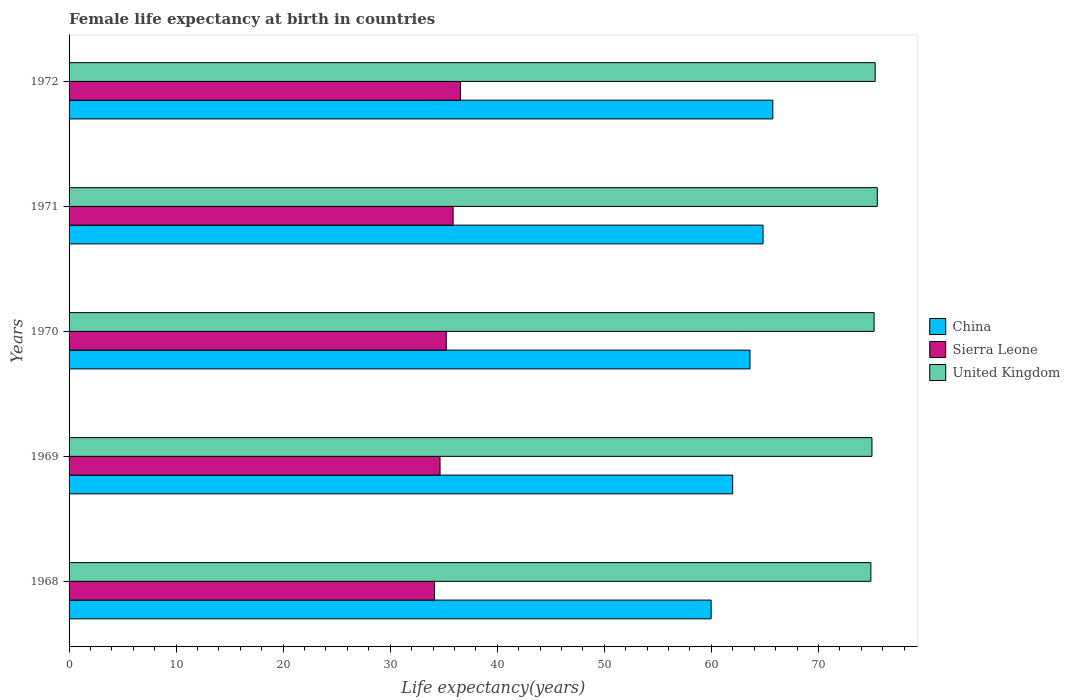Are the number of bars on each tick of the Y-axis equal?
Offer a terse response. Yes. How many bars are there on the 3rd tick from the top?
Your response must be concise. 3. What is the label of the 5th group of bars from the top?
Offer a terse response. 1968. What is the female life expectancy at birth in United Kingdom in 1968?
Make the answer very short. 74.9. Across all years, what is the maximum female life expectancy at birth in Sierra Leone?
Provide a short and direct response. 36.56. Across all years, what is the minimum female life expectancy at birth in China?
Ensure brevity in your answer.  59.98. In which year was the female life expectancy at birth in Sierra Leone minimum?
Your answer should be compact. 1968. What is the total female life expectancy at birth in Sierra Leone in the graph?
Provide a succinct answer. 176.46. What is the difference between the female life expectancy at birth in Sierra Leone in 1970 and that in 1972?
Give a very brief answer. -1.32. What is the difference between the female life expectancy at birth in Sierra Leone in 1970 and the female life expectancy at birth in China in 1968?
Ensure brevity in your answer.  -24.74. What is the average female life expectancy at birth in United Kingdom per year?
Offer a very short reply. 75.18. In the year 1968, what is the difference between the female life expectancy at birth in Sierra Leone and female life expectancy at birth in United Kingdom?
Your answer should be compact. -40.76. In how many years, is the female life expectancy at birth in United Kingdom greater than 30 years?
Your answer should be compact. 5. What is the ratio of the female life expectancy at birth in China in 1969 to that in 1972?
Keep it short and to the point. 0.94. Is the difference between the female life expectancy at birth in Sierra Leone in 1969 and 1972 greater than the difference between the female life expectancy at birth in United Kingdom in 1969 and 1972?
Make the answer very short. No. What is the difference between the highest and the second highest female life expectancy at birth in United Kingdom?
Keep it short and to the point. 0.2. What is the difference between the highest and the lowest female life expectancy at birth in United Kingdom?
Make the answer very short. 0.6. In how many years, is the female life expectancy at birth in United Kingdom greater than the average female life expectancy at birth in United Kingdom taken over all years?
Keep it short and to the point. 3. Is the sum of the female life expectancy at birth in China in 1970 and 1971 greater than the maximum female life expectancy at birth in United Kingdom across all years?
Provide a short and direct response. Yes. What does the 2nd bar from the top in 1971 represents?
Make the answer very short. Sierra Leone. What does the 2nd bar from the bottom in 1970 represents?
Make the answer very short. Sierra Leone. Is it the case that in every year, the sum of the female life expectancy at birth in Sierra Leone and female life expectancy at birth in China is greater than the female life expectancy at birth in United Kingdom?
Offer a very short reply. Yes. How many bars are there?
Provide a short and direct response. 15. Are the values on the major ticks of X-axis written in scientific E-notation?
Provide a succinct answer. No. Does the graph contain any zero values?
Your answer should be very brief. No. Does the graph contain grids?
Your answer should be compact. No. Where does the legend appear in the graph?
Offer a very short reply. Center right. How many legend labels are there?
Give a very brief answer. 3. What is the title of the graph?
Your response must be concise. Female life expectancy at birth in countries. Does "Jordan" appear as one of the legend labels in the graph?
Ensure brevity in your answer.  No. What is the label or title of the X-axis?
Make the answer very short. Life expectancy(years). What is the Life expectancy(years) in China in 1968?
Ensure brevity in your answer.  59.98. What is the Life expectancy(years) in Sierra Leone in 1968?
Ensure brevity in your answer.  34.14. What is the Life expectancy(years) of United Kingdom in 1968?
Ensure brevity in your answer.  74.9. What is the Life expectancy(years) of China in 1969?
Your answer should be very brief. 61.99. What is the Life expectancy(years) in Sierra Leone in 1969?
Ensure brevity in your answer.  34.66. What is the Life expectancy(years) in United Kingdom in 1969?
Your response must be concise. 75. What is the Life expectancy(years) in China in 1970?
Give a very brief answer. 63.61. What is the Life expectancy(years) of Sierra Leone in 1970?
Make the answer very short. 35.23. What is the Life expectancy(years) of United Kingdom in 1970?
Provide a succinct answer. 75.2. What is the Life expectancy(years) in China in 1971?
Your answer should be compact. 64.83. What is the Life expectancy(years) in Sierra Leone in 1971?
Make the answer very short. 35.88. What is the Life expectancy(years) in United Kingdom in 1971?
Your response must be concise. 75.5. What is the Life expectancy(years) in China in 1972?
Provide a succinct answer. 65.74. What is the Life expectancy(years) in Sierra Leone in 1972?
Make the answer very short. 36.56. What is the Life expectancy(years) in United Kingdom in 1972?
Keep it short and to the point. 75.3. Across all years, what is the maximum Life expectancy(years) in China?
Offer a very short reply. 65.74. Across all years, what is the maximum Life expectancy(years) in Sierra Leone?
Make the answer very short. 36.56. Across all years, what is the maximum Life expectancy(years) in United Kingdom?
Offer a terse response. 75.5. Across all years, what is the minimum Life expectancy(years) of China?
Offer a very short reply. 59.98. Across all years, what is the minimum Life expectancy(years) of Sierra Leone?
Ensure brevity in your answer.  34.14. Across all years, what is the minimum Life expectancy(years) in United Kingdom?
Your response must be concise. 74.9. What is the total Life expectancy(years) in China in the graph?
Give a very brief answer. 316.15. What is the total Life expectancy(years) of Sierra Leone in the graph?
Offer a terse response. 176.46. What is the total Life expectancy(years) of United Kingdom in the graph?
Offer a terse response. 375.9. What is the difference between the Life expectancy(years) of China in 1968 and that in 1969?
Your answer should be compact. -2.01. What is the difference between the Life expectancy(years) of Sierra Leone in 1968 and that in 1969?
Your answer should be compact. -0.52. What is the difference between the Life expectancy(years) of China in 1968 and that in 1970?
Your answer should be compact. -3.63. What is the difference between the Life expectancy(years) of Sierra Leone in 1968 and that in 1970?
Offer a very short reply. -1.1. What is the difference between the Life expectancy(years) in United Kingdom in 1968 and that in 1970?
Ensure brevity in your answer.  -0.3. What is the difference between the Life expectancy(years) of China in 1968 and that in 1971?
Make the answer very short. -4.85. What is the difference between the Life expectancy(years) in Sierra Leone in 1968 and that in 1971?
Provide a succinct answer. -1.74. What is the difference between the Life expectancy(years) of China in 1968 and that in 1972?
Your answer should be very brief. -5.76. What is the difference between the Life expectancy(years) of Sierra Leone in 1968 and that in 1972?
Provide a succinct answer. -2.42. What is the difference between the Life expectancy(years) in China in 1969 and that in 1970?
Give a very brief answer. -1.62. What is the difference between the Life expectancy(years) of Sierra Leone in 1969 and that in 1970?
Keep it short and to the point. -0.58. What is the difference between the Life expectancy(years) in United Kingdom in 1969 and that in 1970?
Offer a very short reply. -0.2. What is the difference between the Life expectancy(years) in China in 1969 and that in 1971?
Your answer should be compact. -2.84. What is the difference between the Life expectancy(years) of Sierra Leone in 1969 and that in 1971?
Offer a very short reply. -1.22. What is the difference between the Life expectancy(years) of China in 1969 and that in 1972?
Offer a very short reply. -3.75. What is the difference between the Life expectancy(years) of Sierra Leone in 1969 and that in 1972?
Ensure brevity in your answer.  -1.9. What is the difference between the Life expectancy(years) in United Kingdom in 1969 and that in 1972?
Provide a succinct answer. -0.3. What is the difference between the Life expectancy(years) of China in 1970 and that in 1971?
Offer a very short reply. -1.22. What is the difference between the Life expectancy(years) of Sierra Leone in 1970 and that in 1971?
Give a very brief answer. -0.64. What is the difference between the Life expectancy(years) of China in 1970 and that in 1972?
Make the answer very short. -2.13. What is the difference between the Life expectancy(years) in Sierra Leone in 1970 and that in 1972?
Your answer should be compact. -1.32. What is the difference between the Life expectancy(years) in China in 1971 and that in 1972?
Keep it short and to the point. -0.91. What is the difference between the Life expectancy(years) of Sierra Leone in 1971 and that in 1972?
Your answer should be compact. -0.68. What is the difference between the Life expectancy(years) of United Kingdom in 1971 and that in 1972?
Your response must be concise. 0.2. What is the difference between the Life expectancy(years) in China in 1968 and the Life expectancy(years) in Sierra Leone in 1969?
Provide a short and direct response. 25.32. What is the difference between the Life expectancy(years) of China in 1968 and the Life expectancy(years) of United Kingdom in 1969?
Provide a succinct answer. -15.02. What is the difference between the Life expectancy(years) in Sierra Leone in 1968 and the Life expectancy(years) in United Kingdom in 1969?
Provide a succinct answer. -40.86. What is the difference between the Life expectancy(years) of China in 1968 and the Life expectancy(years) of Sierra Leone in 1970?
Your response must be concise. 24.74. What is the difference between the Life expectancy(years) in China in 1968 and the Life expectancy(years) in United Kingdom in 1970?
Your response must be concise. -15.22. What is the difference between the Life expectancy(years) of Sierra Leone in 1968 and the Life expectancy(years) of United Kingdom in 1970?
Your response must be concise. -41.06. What is the difference between the Life expectancy(years) in China in 1968 and the Life expectancy(years) in Sierra Leone in 1971?
Make the answer very short. 24.1. What is the difference between the Life expectancy(years) of China in 1968 and the Life expectancy(years) of United Kingdom in 1971?
Provide a short and direct response. -15.52. What is the difference between the Life expectancy(years) of Sierra Leone in 1968 and the Life expectancy(years) of United Kingdom in 1971?
Keep it short and to the point. -41.36. What is the difference between the Life expectancy(years) of China in 1968 and the Life expectancy(years) of Sierra Leone in 1972?
Ensure brevity in your answer.  23.42. What is the difference between the Life expectancy(years) in China in 1968 and the Life expectancy(years) in United Kingdom in 1972?
Make the answer very short. -15.32. What is the difference between the Life expectancy(years) of Sierra Leone in 1968 and the Life expectancy(years) of United Kingdom in 1972?
Provide a short and direct response. -41.16. What is the difference between the Life expectancy(years) of China in 1969 and the Life expectancy(years) of Sierra Leone in 1970?
Ensure brevity in your answer.  26.75. What is the difference between the Life expectancy(years) of China in 1969 and the Life expectancy(years) of United Kingdom in 1970?
Offer a very short reply. -13.21. What is the difference between the Life expectancy(years) in Sierra Leone in 1969 and the Life expectancy(years) in United Kingdom in 1970?
Offer a very short reply. -40.55. What is the difference between the Life expectancy(years) of China in 1969 and the Life expectancy(years) of Sierra Leone in 1971?
Offer a terse response. 26.11. What is the difference between the Life expectancy(years) in China in 1969 and the Life expectancy(years) in United Kingdom in 1971?
Make the answer very short. -13.51. What is the difference between the Life expectancy(years) of Sierra Leone in 1969 and the Life expectancy(years) of United Kingdom in 1971?
Your answer should be compact. -40.84. What is the difference between the Life expectancy(years) in China in 1969 and the Life expectancy(years) in Sierra Leone in 1972?
Offer a terse response. 25.43. What is the difference between the Life expectancy(years) in China in 1969 and the Life expectancy(years) in United Kingdom in 1972?
Your answer should be very brief. -13.31. What is the difference between the Life expectancy(years) in Sierra Leone in 1969 and the Life expectancy(years) in United Kingdom in 1972?
Your response must be concise. -40.65. What is the difference between the Life expectancy(years) in China in 1970 and the Life expectancy(years) in Sierra Leone in 1971?
Provide a succinct answer. 27.73. What is the difference between the Life expectancy(years) of China in 1970 and the Life expectancy(years) of United Kingdom in 1971?
Offer a terse response. -11.89. What is the difference between the Life expectancy(years) of Sierra Leone in 1970 and the Life expectancy(years) of United Kingdom in 1971?
Offer a very short reply. -40.27. What is the difference between the Life expectancy(years) of China in 1970 and the Life expectancy(years) of Sierra Leone in 1972?
Provide a short and direct response. 27.05. What is the difference between the Life expectancy(years) of China in 1970 and the Life expectancy(years) of United Kingdom in 1972?
Offer a very short reply. -11.69. What is the difference between the Life expectancy(years) in Sierra Leone in 1970 and the Life expectancy(years) in United Kingdom in 1972?
Offer a very short reply. -40.06. What is the difference between the Life expectancy(years) in China in 1971 and the Life expectancy(years) in Sierra Leone in 1972?
Keep it short and to the point. 28.27. What is the difference between the Life expectancy(years) of China in 1971 and the Life expectancy(years) of United Kingdom in 1972?
Ensure brevity in your answer.  -10.47. What is the difference between the Life expectancy(years) in Sierra Leone in 1971 and the Life expectancy(years) in United Kingdom in 1972?
Offer a terse response. -39.42. What is the average Life expectancy(years) of China per year?
Make the answer very short. 63.23. What is the average Life expectancy(years) in Sierra Leone per year?
Your answer should be compact. 35.29. What is the average Life expectancy(years) of United Kingdom per year?
Keep it short and to the point. 75.18. In the year 1968, what is the difference between the Life expectancy(years) of China and Life expectancy(years) of Sierra Leone?
Ensure brevity in your answer.  25.84. In the year 1968, what is the difference between the Life expectancy(years) in China and Life expectancy(years) in United Kingdom?
Give a very brief answer. -14.92. In the year 1968, what is the difference between the Life expectancy(years) of Sierra Leone and Life expectancy(years) of United Kingdom?
Offer a very short reply. -40.76. In the year 1969, what is the difference between the Life expectancy(years) in China and Life expectancy(years) in Sierra Leone?
Provide a succinct answer. 27.34. In the year 1969, what is the difference between the Life expectancy(years) of China and Life expectancy(years) of United Kingdom?
Offer a terse response. -13.01. In the year 1969, what is the difference between the Life expectancy(years) in Sierra Leone and Life expectancy(years) in United Kingdom?
Offer a terse response. -40.34. In the year 1970, what is the difference between the Life expectancy(years) in China and Life expectancy(years) in Sierra Leone?
Your answer should be very brief. 28.38. In the year 1970, what is the difference between the Life expectancy(years) in China and Life expectancy(years) in United Kingdom?
Offer a terse response. -11.59. In the year 1970, what is the difference between the Life expectancy(years) of Sierra Leone and Life expectancy(years) of United Kingdom?
Offer a terse response. -39.97. In the year 1971, what is the difference between the Life expectancy(years) of China and Life expectancy(years) of Sierra Leone?
Provide a short and direct response. 28.95. In the year 1971, what is the difference between the Life expectancy(years) of China and Life expectancy(years) of United Kingdom?
Make the answer very short. -10.67. In the year 1971, what is the difference between the Life expectancy(years) in Sierra Leone and Life expectancy(years) in United Kingdom?
Your answer should be compact. -39.62. In the year 1972, what is the difference between the Life expectancy(years) of China and Life expectancy(years) of Sierra Leone?
Offer a terse response. 29.18. In the year 1972, what is the difference between the Life expectancy(years) of China and Life expectancy(years) of United Kingdom?
Your response must be concise. -9.56. In the year 1972, what is the difference between the Life expectancy(years) of Sierra Leone and Life expectancy(years) of United Kingdom?
Give a very brief answer. -38.74. What is the ratio of the Life expectancy(years) of China in 1968 to that in 1969?
Keep it short and to the point. 0.97. What is the ratio of the Life expectancy(years) in Sierra Leone in 1968 to that in 1969?
Make the answer very short. 0.99. What is the ratio of the Life expectancy(years) in China in 1968 to that in 1970?
Keep it short and to the point. 0.94. What is the ratio of the Life expectancy(years) in Sierra Leone in 1968 to that in 1970?
Your response must be concise. 0.97. What is the ratio of the Life expectancy(years) in China in 1968 to that in 1971?
Make the answer very short. 0.93. What is the ratio of the Life expectancy(years) of Sierra Leone in 1968 to that in 1971?
Offer a very short reply. 0.95. What is the ratio of the Life expectancy(years) in United Kingdom in 1968 to that in 1971?
Make the answer very short. 0.99. What is the ratio of the Life expectancy(years) in China in 1968 to that in 1972?
Make the answer very short. 0.91. What is the ratio of the Life expectancy(years) of Sierra Leone in 1968 to that in 1972?
Make the answer very short. 0.93. What is the ratio of the Life expectancy(years) in United Kingdom in 1968 to that in 1972?
Your answer should be compact. 0.99. What is the ratio of the Life expectancy(years) of China in 1969 to that in 1970?
Provide a succinct answer. 0.97. What is the ratio of the Life expectancy(years) of Sierra Leone in 1969 to that in 1970?
Provide a succinct answer. 0.98. What is the ratio of the Life expectancy(years) in United Kingdom in 1969 to that in 1970?
Offer a very short reply. 1. What is the ratio of the Life expectancy(years) in China in 1969 to that in 1971?
Provide a succinct answer. 0.96. What is the ratio of the Life expectancy(years) in United Kingdom in 1969 to that in 1971?
Your answer should be compact. 0.99. What is the ratio of the Life expectancy(years) of China in 1969 to that in 1972?
Provide a succinct answer. 0.94. What is the ratio of the Life expectancy(years) in Sierra Leone in 1969 to that in 1972?
Give a very brief answer. 0.95. What is the ratio of the Life expectancy(years) in China in 1970 to that in 1971?
Your answer should be very brief. 0.98. What is the ratio of the Life expectancy(years) of Sierra Leone in 1970 to that in 1971?
Your answer should be very brief. 0.98. What is the ratio of the Life expectancy(years) in United Kingdom in 1970 to that in 1971?
Offer a terse response. 1. What is the ratio of the Life expectancy(years) in China in 1970 to that in 1972?
Offer a very short reply. 0.97. What is the ratio of the Life expectancy(years) in Sierra Leone in 1970 to that in 1972?
Keep it short and to the point. 0.96. What is the ratio of the Life expectancy(years) of China in 1971 to that in 1972?
Ensure brevity in your answer.  0.99. What is the ratio of the Life expectancy(years) of Sierra Leone in 1971 to that in 1972?
Provide a succinct answer. 0.98. What is the difference between the highest and the second highest Life expectancy(years) in China?
Offer a terse response. 0.91. What is the difference between the highest and the second highest Life expectancy(years) in Sierra Leone?
Keep it short and to the point. 0.68. What is the difference between the highest and the second highest Life expectancy(years) of United Kingdom?
Make the answer very short. 0.2. What is the difference between the highest and the lowest Life expectancy(years) in China?
Provide a succinct answer. 5.76. What is the difference between the highest and the lowest Life expectancy(years) in Sierra Leone?
Ensure brevity in your answer.  2.42. 